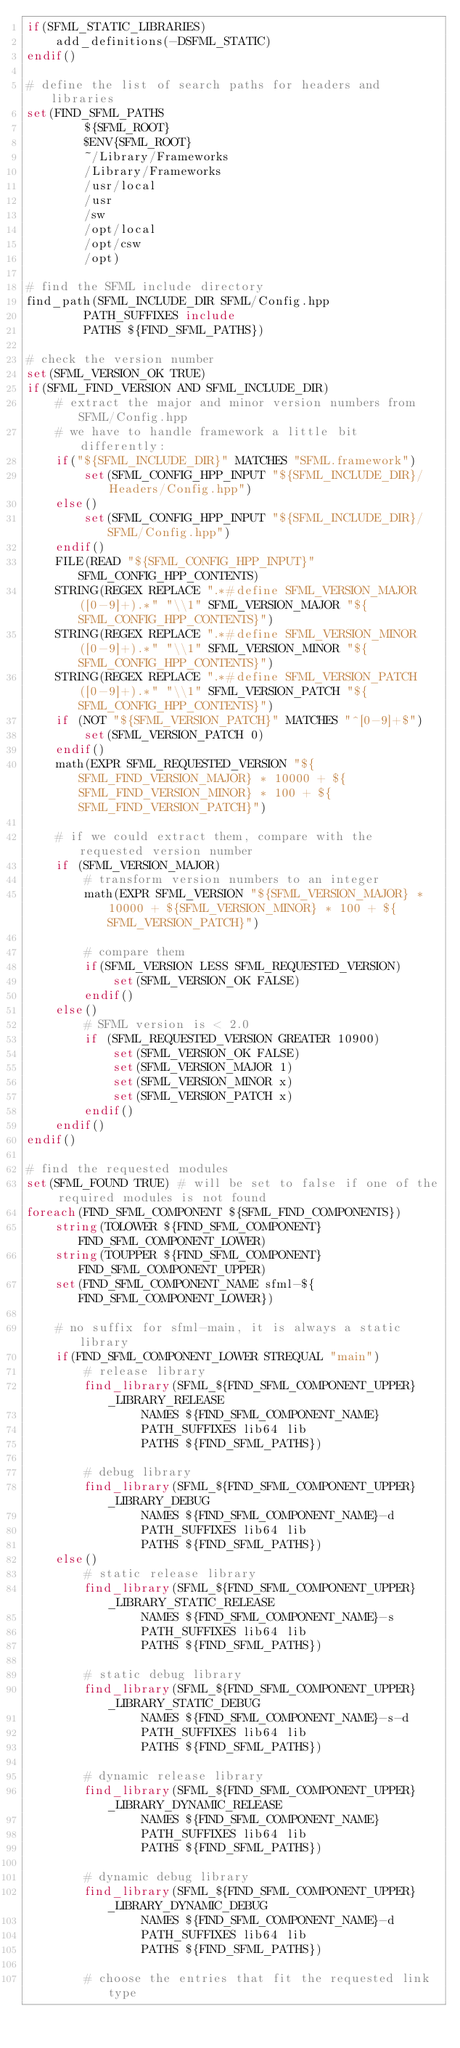Convert code to text. <code><loc_0><loc_0><loc_500><loc_500><_CMake_>if(SFML_STATIC_LIBRARIES)
    add_definitions(-DSFML_STATIC)
endif()

# define the list of search paths for headers and libraries
set(FIND_SFML_PATHS
        ${SFML_ROOT}
        $ENV{SFML_ROOT}
        ~/Library/Frameworks
        /Library/Frameworks
        /usr/local
        /usr
        /sw
        /opt/local
        /opt/csw
        /opt)

# find the SFML include directory
find_path(SFML_INCLUDE_DIR SFML/Config.hpp
        PATH_SUFFIXES include
        PATHS ${FIND_SFML_PATHS})

# check the version number
set(SFML_VERSION_OK TRUE)
if(SFML_FIND_VERSION AND SFML_INCLUDE_DIR)
    # extract the major and minor version numbers from SFML/Config.hpp
    # we have to handle framework a little bit differently:
    if("${SFML_INCLUDE_DIR}" MATCHES "SFML.framework")
        set(SFML_CONFIG_HPP_INPUT "${SFML_INCLUDE_DIR}/Headers/Config.hpp")
    else()
        set(SFML_CONFIG_HPP_INPUT "${SFML_INCLUDE_DIR}/SFML/Config.hpp")
    endif()
    FILE(READ "${SFML_CONFIG_HPP_INPUT}" SFML_CONFIG_HPP_CONTENTS)
    STRING(REGEX REPLACE ".*#define SFML_VERSION_MAJOR ([0-9]+).*" "\\1" SFML_VERSION_MAJOR "${SFML_CONFIG_HPP_CONTENTS}")
    STRING(REGEX REPLACE ".*#define SFML_VERSION_MINOR ([0-9]+).*" "\\1" SFML_VERSION_MINOR "${SFML_CONFIG_HPP_CONTENTS}")
    STRING(REGEX REPLACE ".*#define SFML_VERSION_PATCH ([0-9]+).*" "\\1" SFML_VERSION_PATCH "${SFML_CONFIG_HPP_CONTENTS}")
    if (NOT "${SFML_VERSION_PATCH}" MATCHES "^[0-9]+$")
        set(SFML_VERSION_PATCH 0)
    endif()
    math(EXPR SFML_REQUESTED_VERSION "${SFML_FIND_VERSION_MAJOR} * 10000 + ${SFML_FIND_VERSION_MINOR} * 100 + ${SFML_FIND_VERSION_PATCH}")

    # if we could extract them, compare with the requested version number
    if (SFML_VERSION_MAJOR)
        # transform version numbers to an integer
        math(EXPR SFML_VERSION "${SFML_VERSION_MAJOR} * 10000 + ${SFML_VERSION_MINOR} * 100 + ${SFML_VERSION_PATCH}")

        # compare them
        if(SFML_VERSION LESS SFML_REQUESTED_VERSION)
            set(SFML_VERSION_OK FALSE)
        endif()
    else()
        # SFML version is < 2.0
        if (SFML_REQUESTED_VERSION GREATER 10900)
            set(SFML_VERSION_OK FALSE)
            set(SFML_VERSION_MAJOR 1)
            set(SFML_VERSION_MINOR x)
            set(SFML_VERSION_PATCH x)
        endif()
    endif()
endif()

# find the requested modules
set(SFML_FOUND TRUE) # will be set to false if one of the required modules is not found
foreach(FIND_SFML_COMPONENT ${SFML_FIND_COMPONENTS})
    string(TOLOWER ${FIND_SFML_COMPONENT} FIND_SFML_COMPONENT_LOWER)
    string(TOUPPER ${FIND_SFML_COMPONENT} FIND_SFML_COMPONENT_UPPER)
    set(FIND_SFML_COMPONENT_NAME sfml-${FIND_SFML_COMPONENT_LOWER})

    # no suffix for sfml-main, it is always a static library
    if(FIND_SFML_COMPONENT_LOWER STREQUAL "main")
        # release library
        find_library(SFML_${FIND_SFML_COMPONENT_UPPER}_LIBRARY_RELEASE
                NAMES ${FIND_SFML_COMPONENT_NAME}
                PATH_SUFFIXES lib64 lib
                PATHS ${FIND_SFML_PATHS})

        # debug library
        find_library(SFML_${FIND_SFML_COMPONENT_UPPER}_LIBRARY_DEBUG
                NAMES ${FIND_SFML_COMPONENT_NAME}-d
                PATH_SUFFIXES lib64 lib
                PATHS ${FIND_SFML_PATHS})
    else()
        # static release library
        find_library(SFML_${FIND_SFML_COMPONENT_UPPER}_LIBRARY_STATIC_RELEASE
                NAMES ${FIND_SFML_COMPONENT_NAME}-s
                PATH_SUFFIXES lib64 lib
                PATHS ${FIND_SFML_PATHS})

        # static debug library
        find_library(SFML_${FIND_SFML_COMPONENT_UPPER}_LIBRARY_STATIC_DEBUG
                NAMES ${FIND_SFML_COMPONENT_NAME}-s-d
                PATH_SUFFIXES lib64 lib
                PATHS ${FIND_SFML_PATHS})

        # dynamic release library
        find_library(SFML_${FIND_SFML_COMPONENT_UPPER}_LIBRARY_DYNAMIC_RELEASE
                NAMES ${FIND_SFML_COMPONENT_NAME}
                PATH_SUFFIXES lib64 lib
                PATHS ${FIND_SFML_PATHS})

        # dynamic debug library
        find_library(SFML_${FIND_SFML_COMPONENT_UPPER}_LIBRARY_DYNAMIC_DEBUG
                NAMES ${FIND_SFML_COMPONENT_NAME}-d
                PATH_SUFFIXES lib64 lib
                PATHS ${FIND_SFML_PATHS})

        # choose the entries that fit the requested link type</code> 